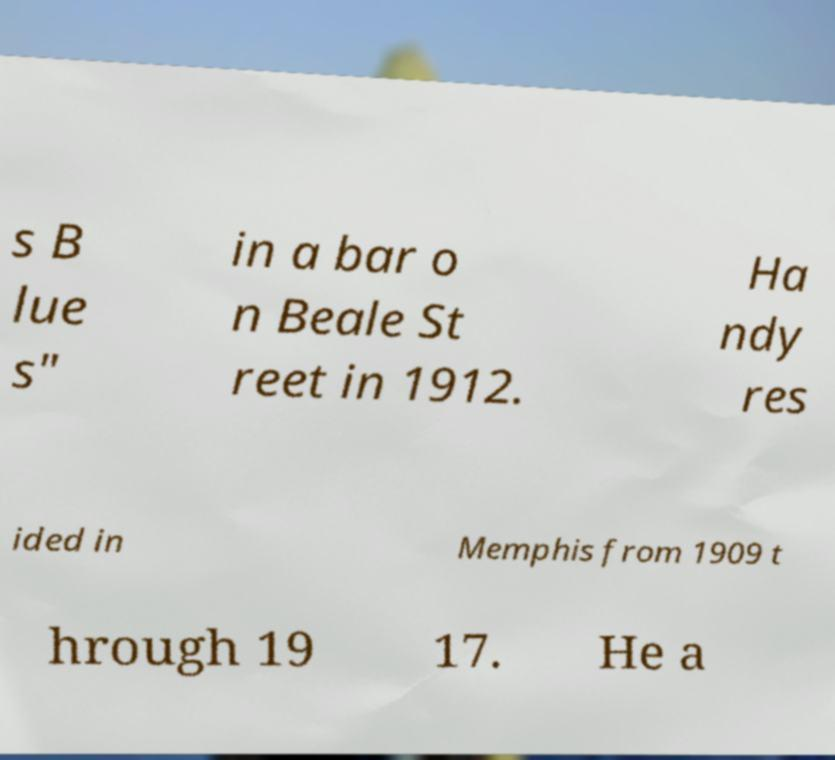Can you accurately transcribe the text from the provided image for me? s B lue s" in a bar o n Beale St reet in 1912. Ha ndy res ided in Memphis from 1909 t hrough 19 17. He a 